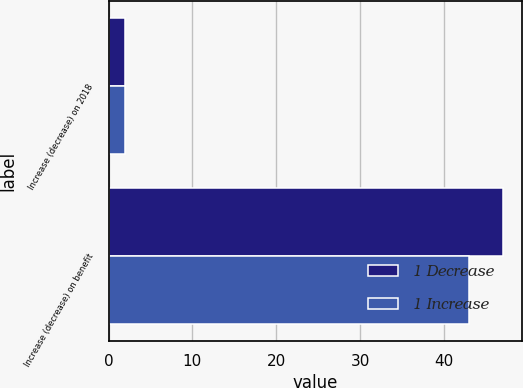Convert chart to OTSL. <chart><loc_0><loc_0><loc_500><loc_500><stacked_bar_chart><ecel><fcel>Increase (decrease) on 2018<fcel>Increase (decrease) on benefit<nl><fcel>1 Decrease<fcel>2<fcel>47<nl><fcel>1 Increase<fcel>2<fcel>43<nl></chart> 